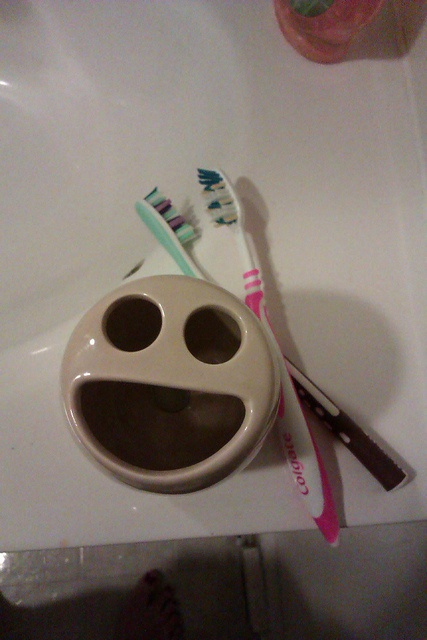Describe the objects in this image and their specific colors. I can see sink in darkgray, gray, and black tones, people in gray and black tones, toothbrush in gray, darkgray, and maroon tones, and toothbrush in gray, black, darkgray, and teal tones in this image. 